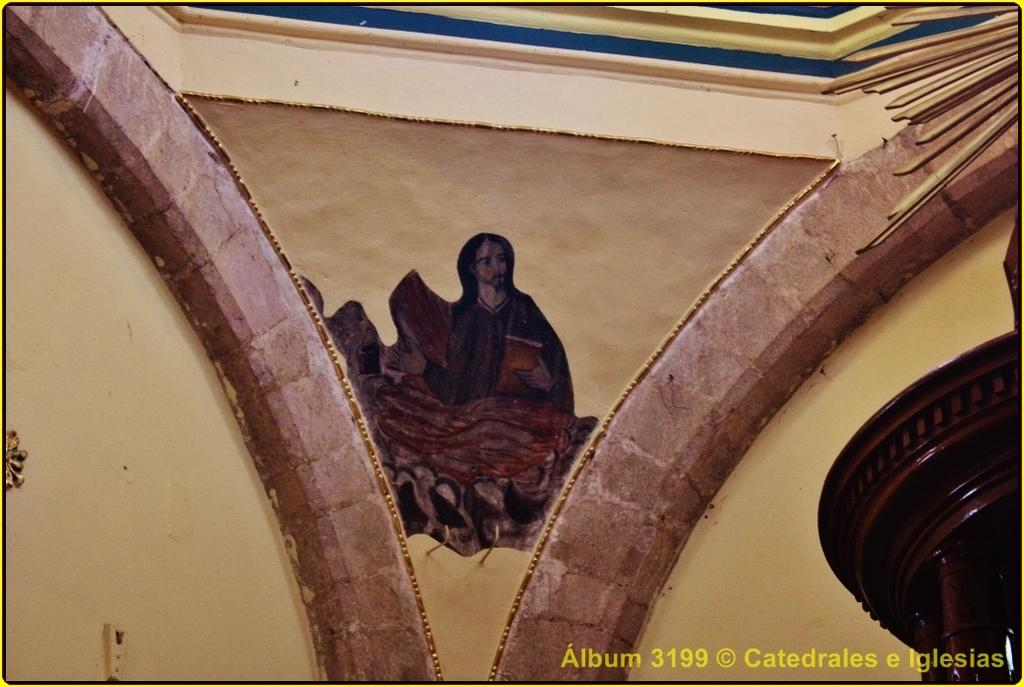What is depicted on the wall in the image? There is an image of a person on the wall. What object can be seen in the image besides the wall? There is a stand in the image. Is there any text present in the image? Yes, there is some text at the bottom of the image. What type of sail is being used by the person in the image? There is no sail present in the image; it features an image of a person on the wall and a stand. How is the wax being applied to the person's face in the image? There is no wax or any indication of a person applying it in the image. 